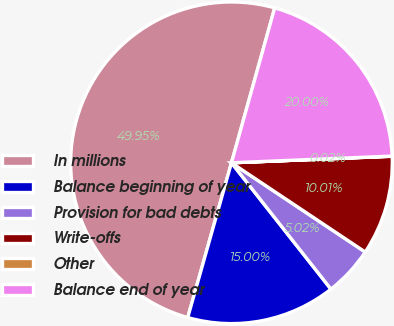Convert chart to OTSL. <chart><loc_0><loc_0><loc_500><loc_500><pie_chart><fcel>In millions<fcel>Balance beginning of year<fcel>Provision for bad debts<fcel>Write-offs<fcel>Other<fcel>Balance end of year<nl><fcel>49.95%<fcel>15.0%<fcel>5.02%<fcel>10.01%<fcel>0.02%<fcel>20.0%<nl></chart> 